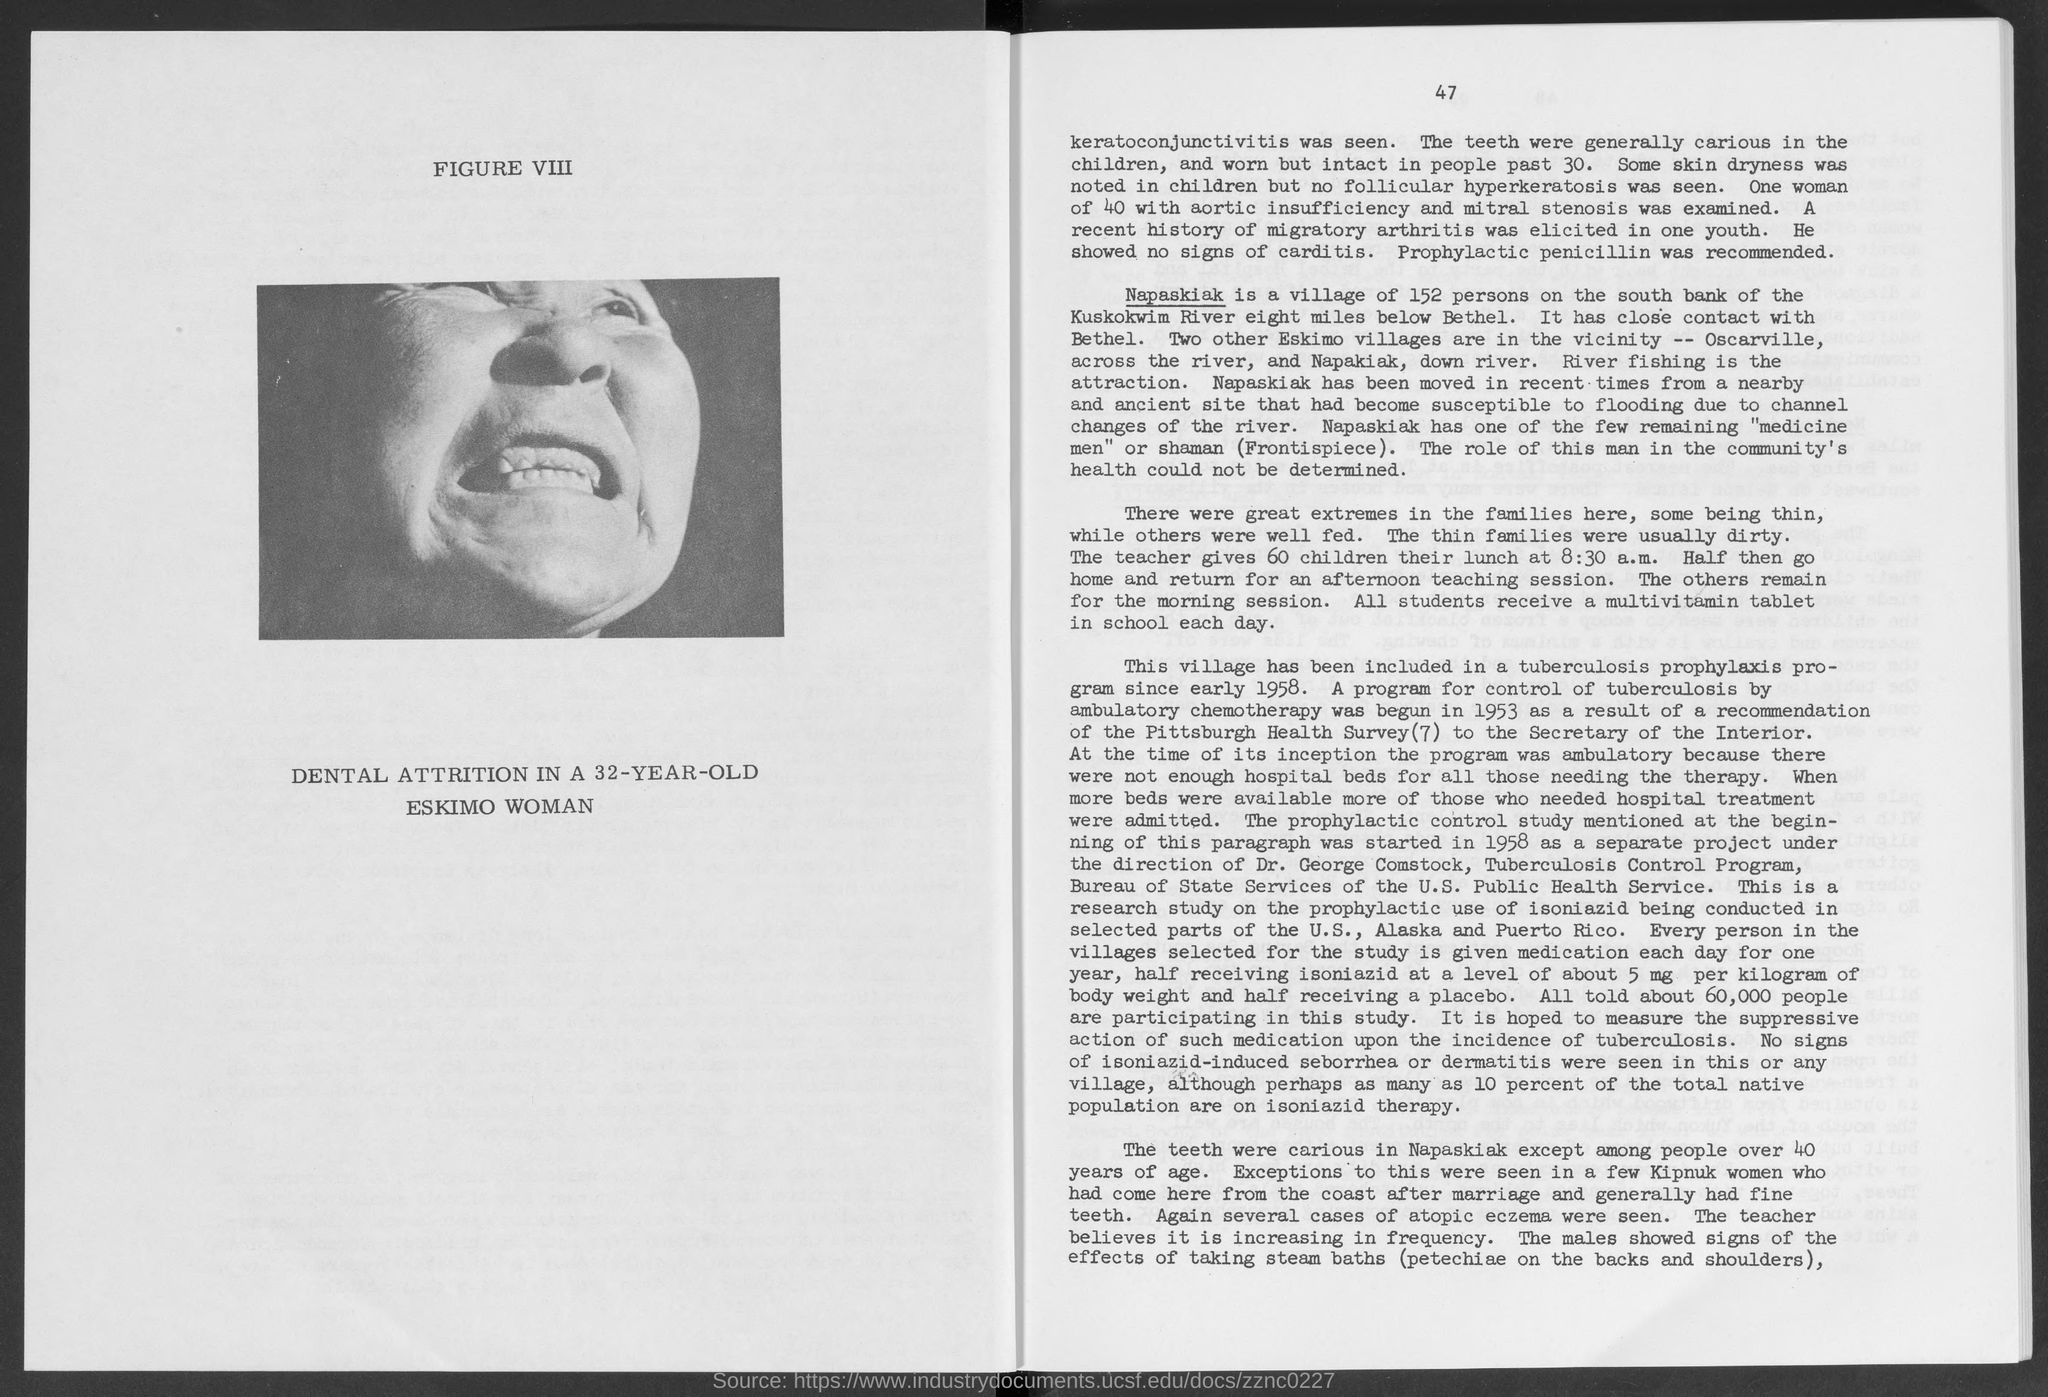Indicate a few pertinent items in this graphic. A 32-year-old Eskimo woman is shown to have dental attrition, which is a condition characterized by the wearing down of tooth enamel due to grinding or clenching of the teeth. The image depicts "what is written above the picture?" specifically "figure viii..". The time mentioned in the third paragraph is 8:30 a.m. 